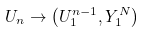<formula> <loc_0><loc_0><loc_500><loc_500>U _ { n } \rightarrow \left ( U _ { 1 } ^ { n - 1 } , Y _ { 1 } ^ { N } \right )</formula> 